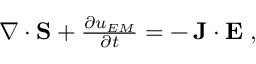<formula> <loc_0><loc_0><loc_500><loc_500>\begin{array} { r } { \nabla \cdot { S } + \frac { \partial u _ { E M } } { \partial t } = - \, { J } \cdot { E } \, , } \end{array}</formula> 